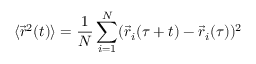<formula> <loc_0><loc_0><loc_500><loc_500>\langle \vec { r } ^ { 2 } ( t ) \rangle = \frac { 1 } { N } \sum _ { i = 1 } ^ { N } ( \vec { r } _ { i } ( \tau + t ) - \vec { r } _ { i } ( \tau ) ) ^ { 2 }</formula> 